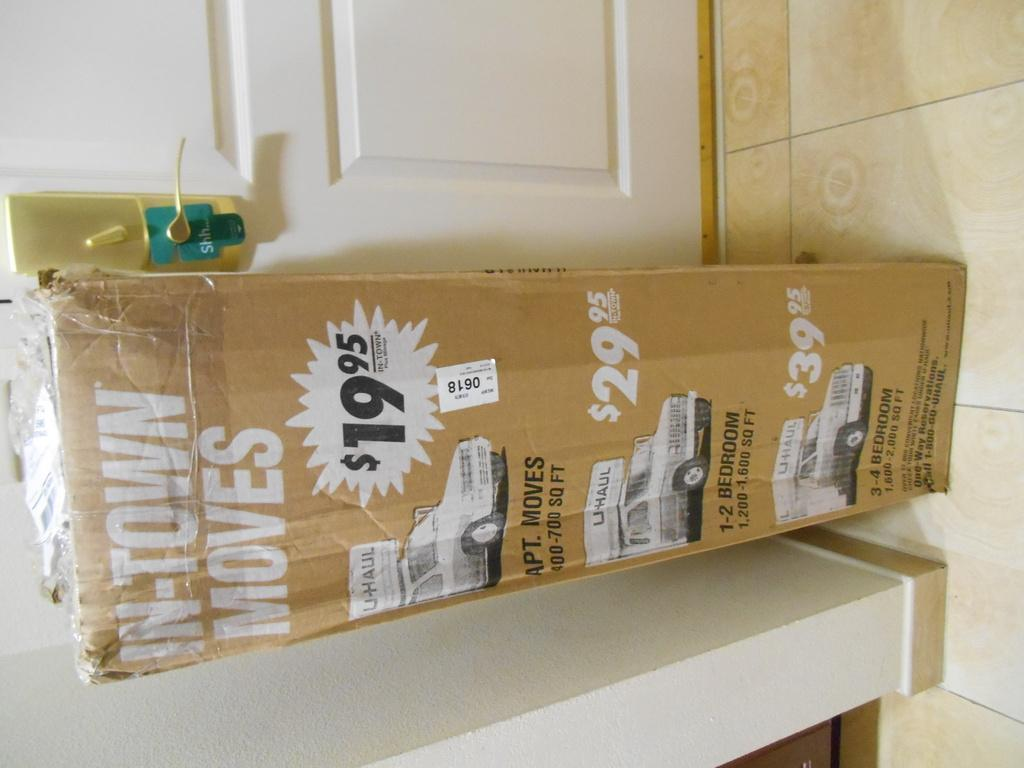<image>
Describe the image concisely. A taped box advertises the moving company U-Haul. 